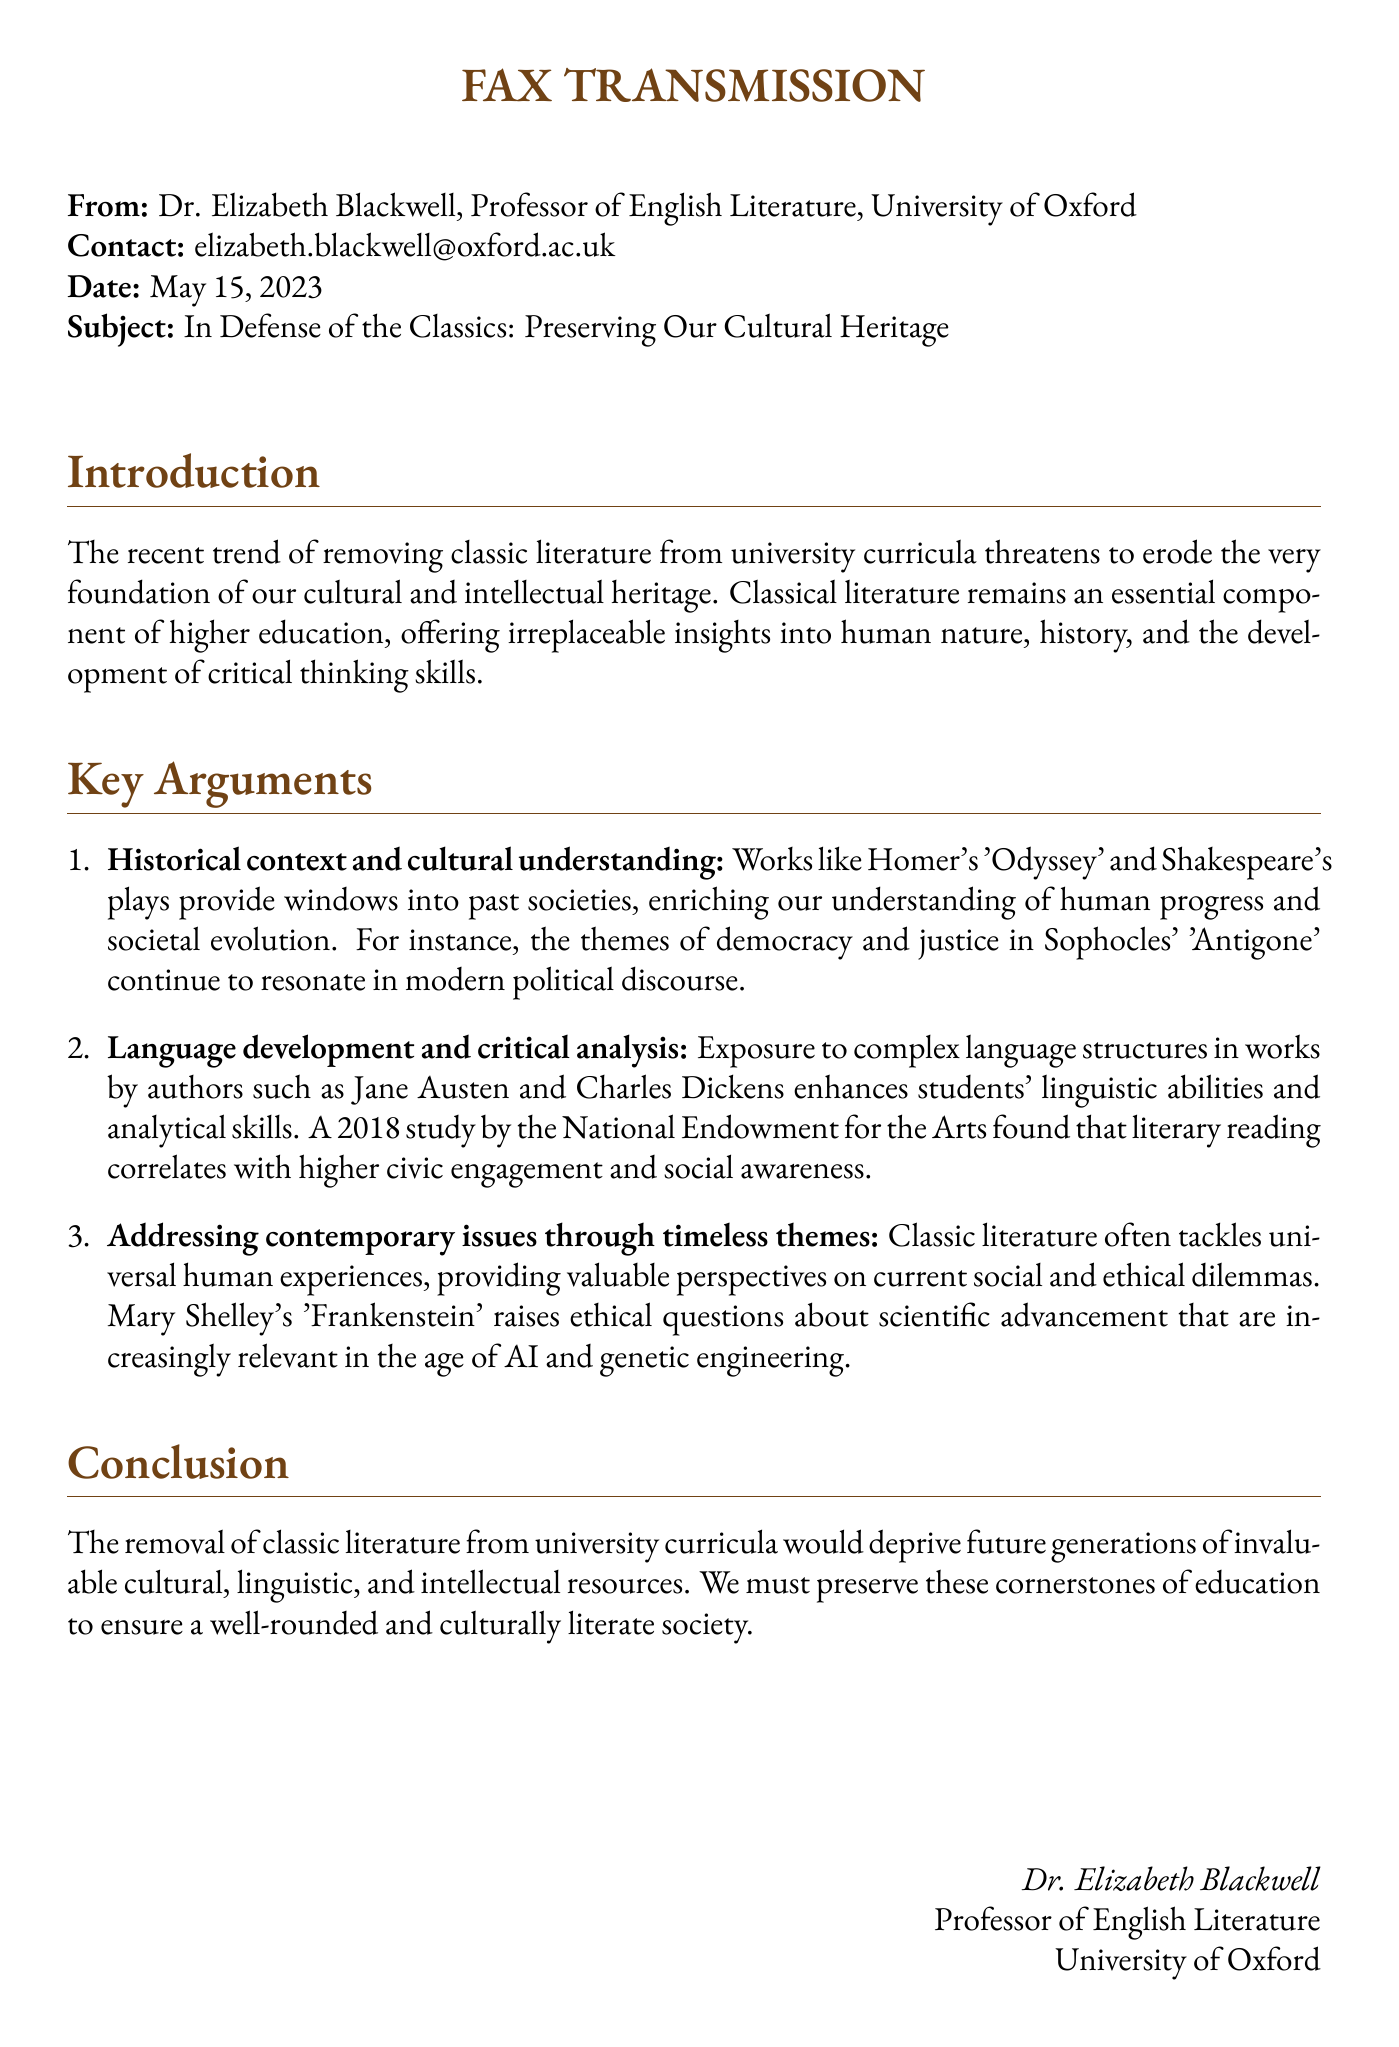What is the date of the fax? The date is explicitly stated in the document.
Answer: May 15, 2023 Who is the sender of the fax? The sender's name is provided at the top of the document.
Answer: Dr. Elizabeth Blackwell What university does Dr. Blackwell represent? The document specifies the university associated with the sender.
Answer: University of Oxford What is one example of classical literature mentioned in the document? The document lists examples of classical works to support its argument.
Answer: Homer's 'Odyssey' What key theme in classic literature is referenced in the context of contemporary issues? The document discusses specific themes in classics that relate to current societal topics.
Answer: Ethical questions about scientific advancement What organization conducted the study mentioned in the document? The study mentioned in the document identifies a specific institution.
Answer: National Endowment for the Arts How does the document categorize its main arguments? The structure of the fax includes a specific way of categorizing arguments.
Answer: Key Arguments What is one of the intended outcomes of preserving classic literature according to the document? The document states a specific goal related to future generations.
Answer: A well-rounded and culturally literate society What type of literature is the focus of the op-ed? The focus of the document is described at the beginning.
Answer: Classic literature 